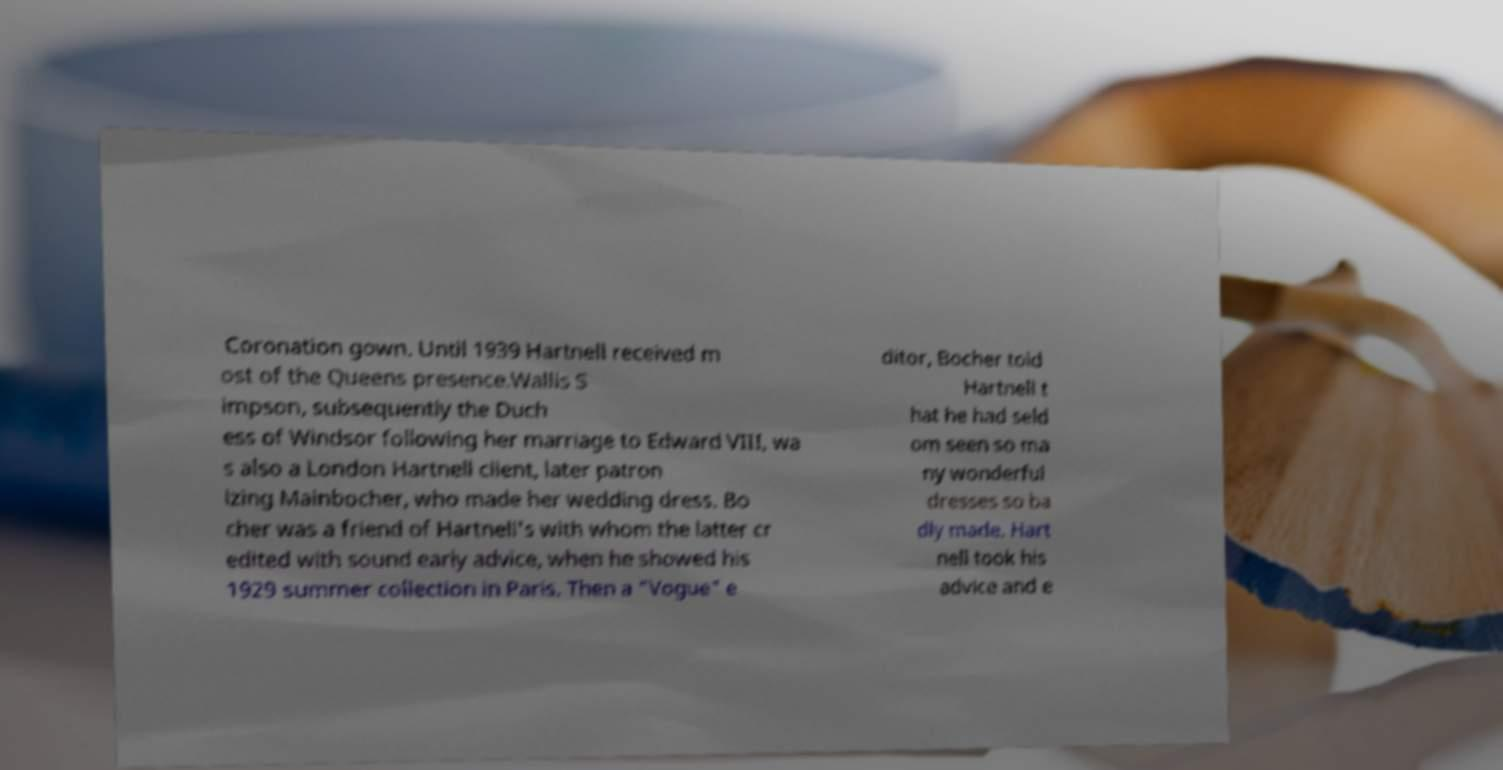Can you read and provide the text displayed in the image?This photo seems to have some interesting text. Can you extract and type it out for me? Coronation gown. Until 1939 Hartnell received m ost of the Queens presence.Wallis S impson, subsequently the Duch ess of Windsor following her marriage to Edward VIII, wa s also a London Hartnell client, later patron izing Mainbocher, who made her wedding dress. Bo cher was a friend of Hartnell's with whom the latter cr edited with sound early advice, when he showed his 1929 summer collection in Paris. Then a "Vogue" e ditor, Bocher told Hartnell t hat he had seld om seen so ma ny wonderful dresses so ba dly made. Hart nell took his advice and e 